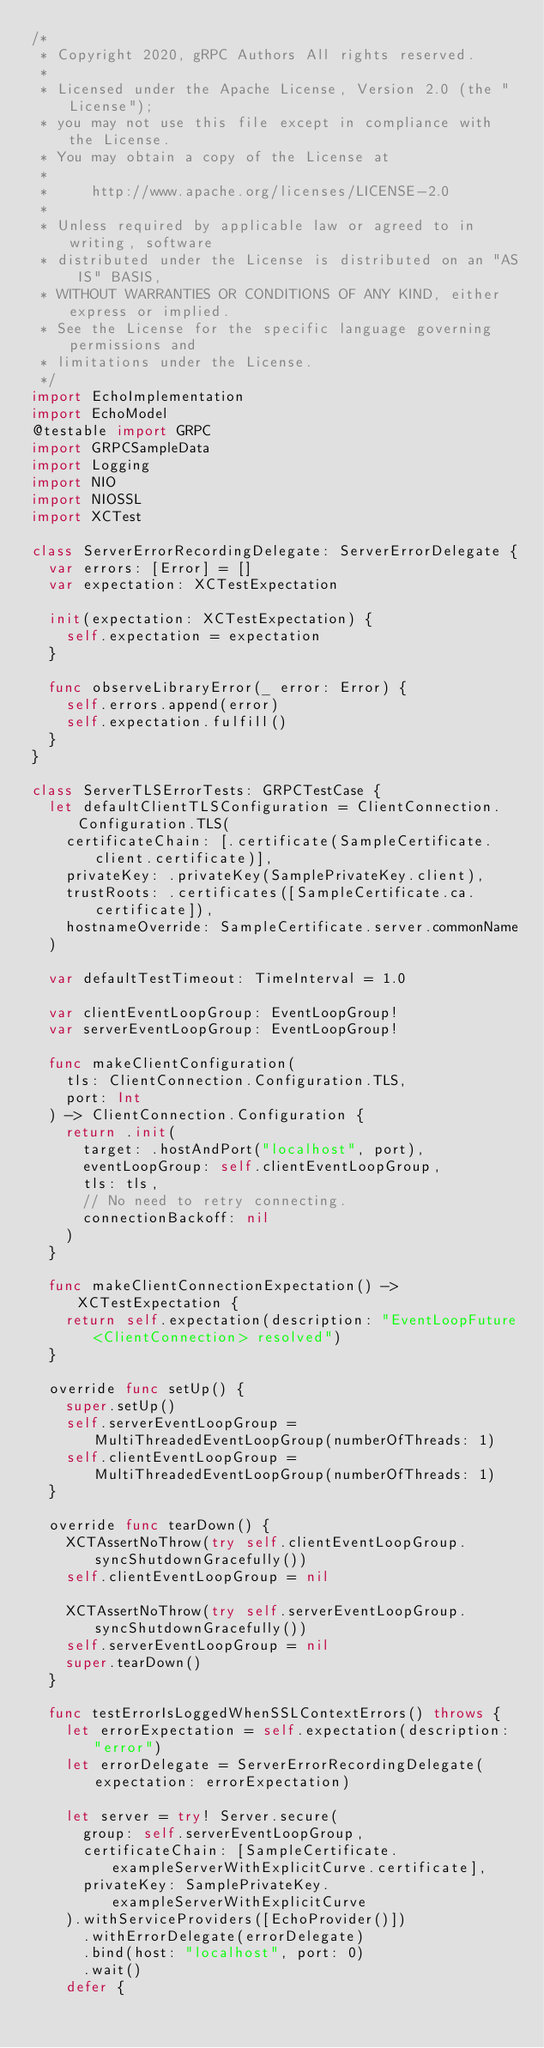Convert code to text. <code><loc_0><loc_0><loc_500><loc_500><_Swift_>/*
 * Copyright 2020, gRPC Authors All rights reserved.
 *
 * Licensed under the Apache License, Version 2.0 (the "License");
 * you may not use this file except in compliance with the License.
 * You may obtain a copy of the License at
 *
 *     http://www.apache.org/licenses/LICENSE-2.0
 *
 * Unless required by applicable law or agreed to in writing, software
 * distributed under the License is distributed on an "AS IS" BASIS,
 * WITHOUT WARRANTIES OR CONDITIONS OF ANY KIND, either express or implied.
 * See the License for the specific language governing permissions and
 * limitations under the License.
 */
import EchoImplementation
import EchoModel
@testable import GRPC
import GRPCSampleData
import Logging
import NIO
import NIOSSL
import XCTest

class ServerErrorRecordingDelegate: ServerErrorDelegate {
  var errors: [Error] = []
  var expectation: XCTestExpectation

  init(expectation: XCTestExpectation) {
    self.expectation = expectation
  }

  func observeLibraryError(_ error: Error) {
    self.errors.append(error)
    self.expectation.fulfill()
  }
}

class ServerTLSErrorTests: GRPCTestCase {
  let defaultClientTLSConfiguration = ClientConnection.Configuration.TLS(
    certificateChain: [.certificate(SampleCertificate.client.certificate)],
    privateKey: .privateKey(SamplePrivateKey.client),
    trustRoots: .certificates([SampleCertificate.ca.certificate]),
    hostnameOverride: SampleCertificate.server.commonName
  )

  var defaultTestTimeout: TimeInterval = 1.0

  var clientEventLoopGroup: EventLoopGroup!
  var serverEventLoopGroup: EventLoopGroup!

  func makeClientConfiguration(
    tls: ClientConnection.Configuration.TLS,
    port: Int
  ) -> ClientConnection.Configuration {
    return .init(
      target: .hostAndPort("localhost", port),
      eventLoopGroup: self.clientEventLoopGroup,
      tls: tls,
      // No need to retry connecting.
      connectionBackoff: nil
    )
  }

  func makeClientConnectionExpectation() -> XCTestExpectation {
    return self.expectation(description: "EventLoopFuture<ClientConnection> resolved")
  }

  override func setUp() {
    super.setUp()
    self.serverEventLoopGroup = MultiThreadedEventLoopGroup(numberOfThreads: 1)
    self.clientEventLoopGroup = MultiThreadedEventLoopGroup(numberOfThreads: 1)
  }

  override func tearDown() {
    XCTAssertNoThrow(try self.clientEventLoopGroup.syncShutdownGracefully())
    self.clientEventLoopGroup = nil

    XCTAssertNoThrow(try self.serverEventLoopGroup.syncShutdownGracefully())
    self.serverEventLoopGroup = nil
    super.tearDown()
  }

  func testErrorIsLoggedWhenSSLContextErrors() throws {
    let errorExpectation = self.expectation(description: "error")
    let errorDelegate = ServerErrorRecordingDelegate(expectation: errorExpectation)

    let server = try! Server.secure(
      group: self.serverEventLoopGroup,
      certificateChain: [SampleCertificate.exampleServerWithExplicitCurve.certificate],
      privateKey: SamplePrivateKey.exampleServerWithExplicitCurve
    ).withServiceProviders([EchoProvider()])
      .withErrorDelegate(errorDelegate)
      .bind(host: "localhost", port: 0)
      .wait()
    defer {</code> 